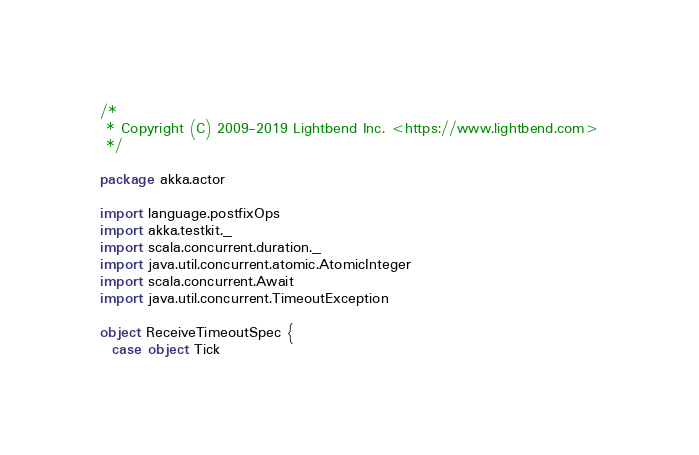Convert code to text. <code><loc_0><loc_0><loc_500><loc_500><_Scala_>/*
 * Copyright (C) 2009-2019 Lightbend Inc. <https://www.lightbend.com>
 */

package akka.actor

import language.postfixOps
import akka.testkit._
import scala.concurrent.duration._
import java.util.concurrent.atomic.AtomicInteger
import scala.concurrent.Await
import java.util.concurrent.TimeoutException

object ReceiveTimeoutSpec {
  case object Tick</code> 